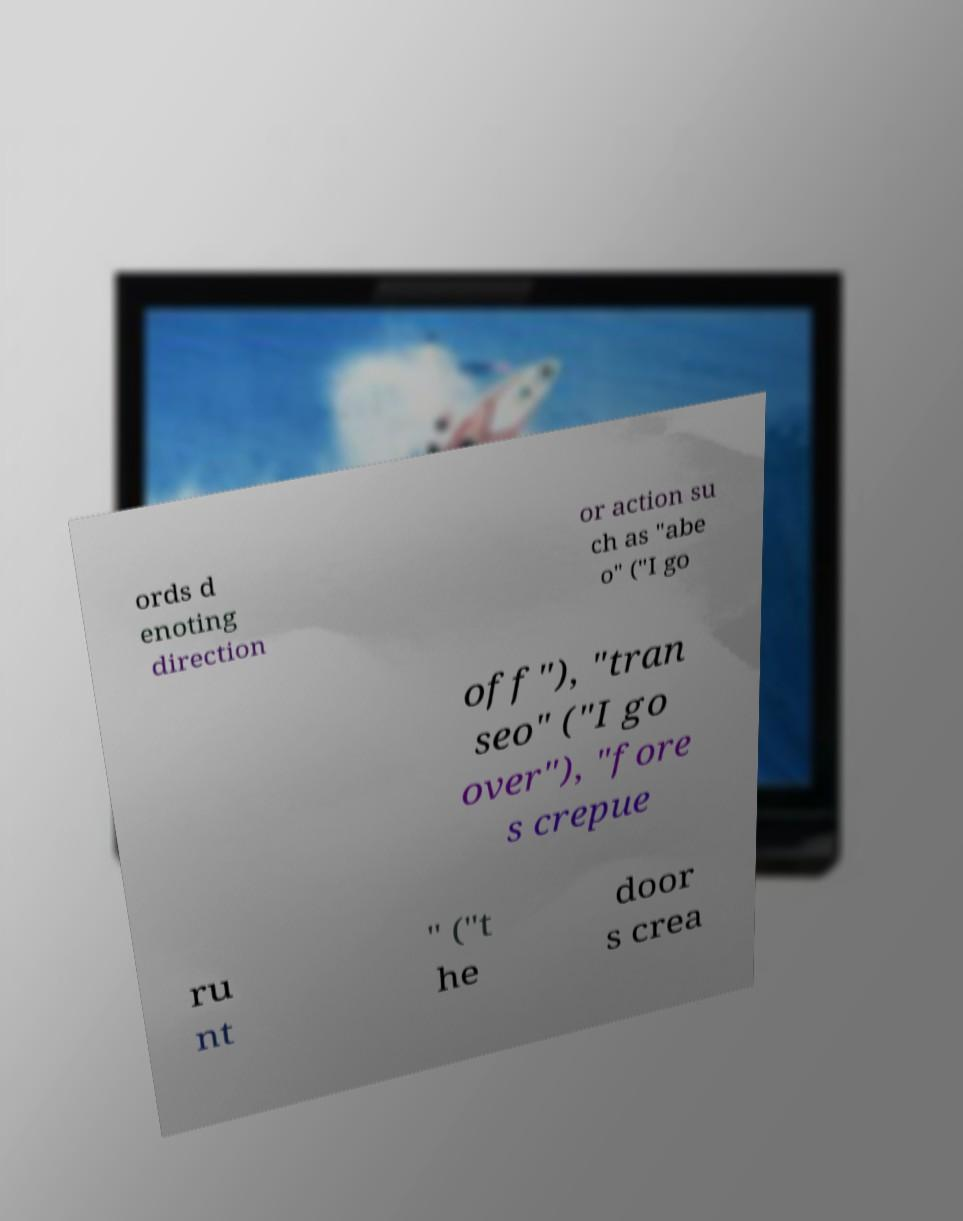Please identify and transcribe the text found in this image. ords d enoting direction or action su ch as "abe o" ("I go off"), "tran seo" ("I go over"), "fore s crepue ru nt " ("t he door s crea 